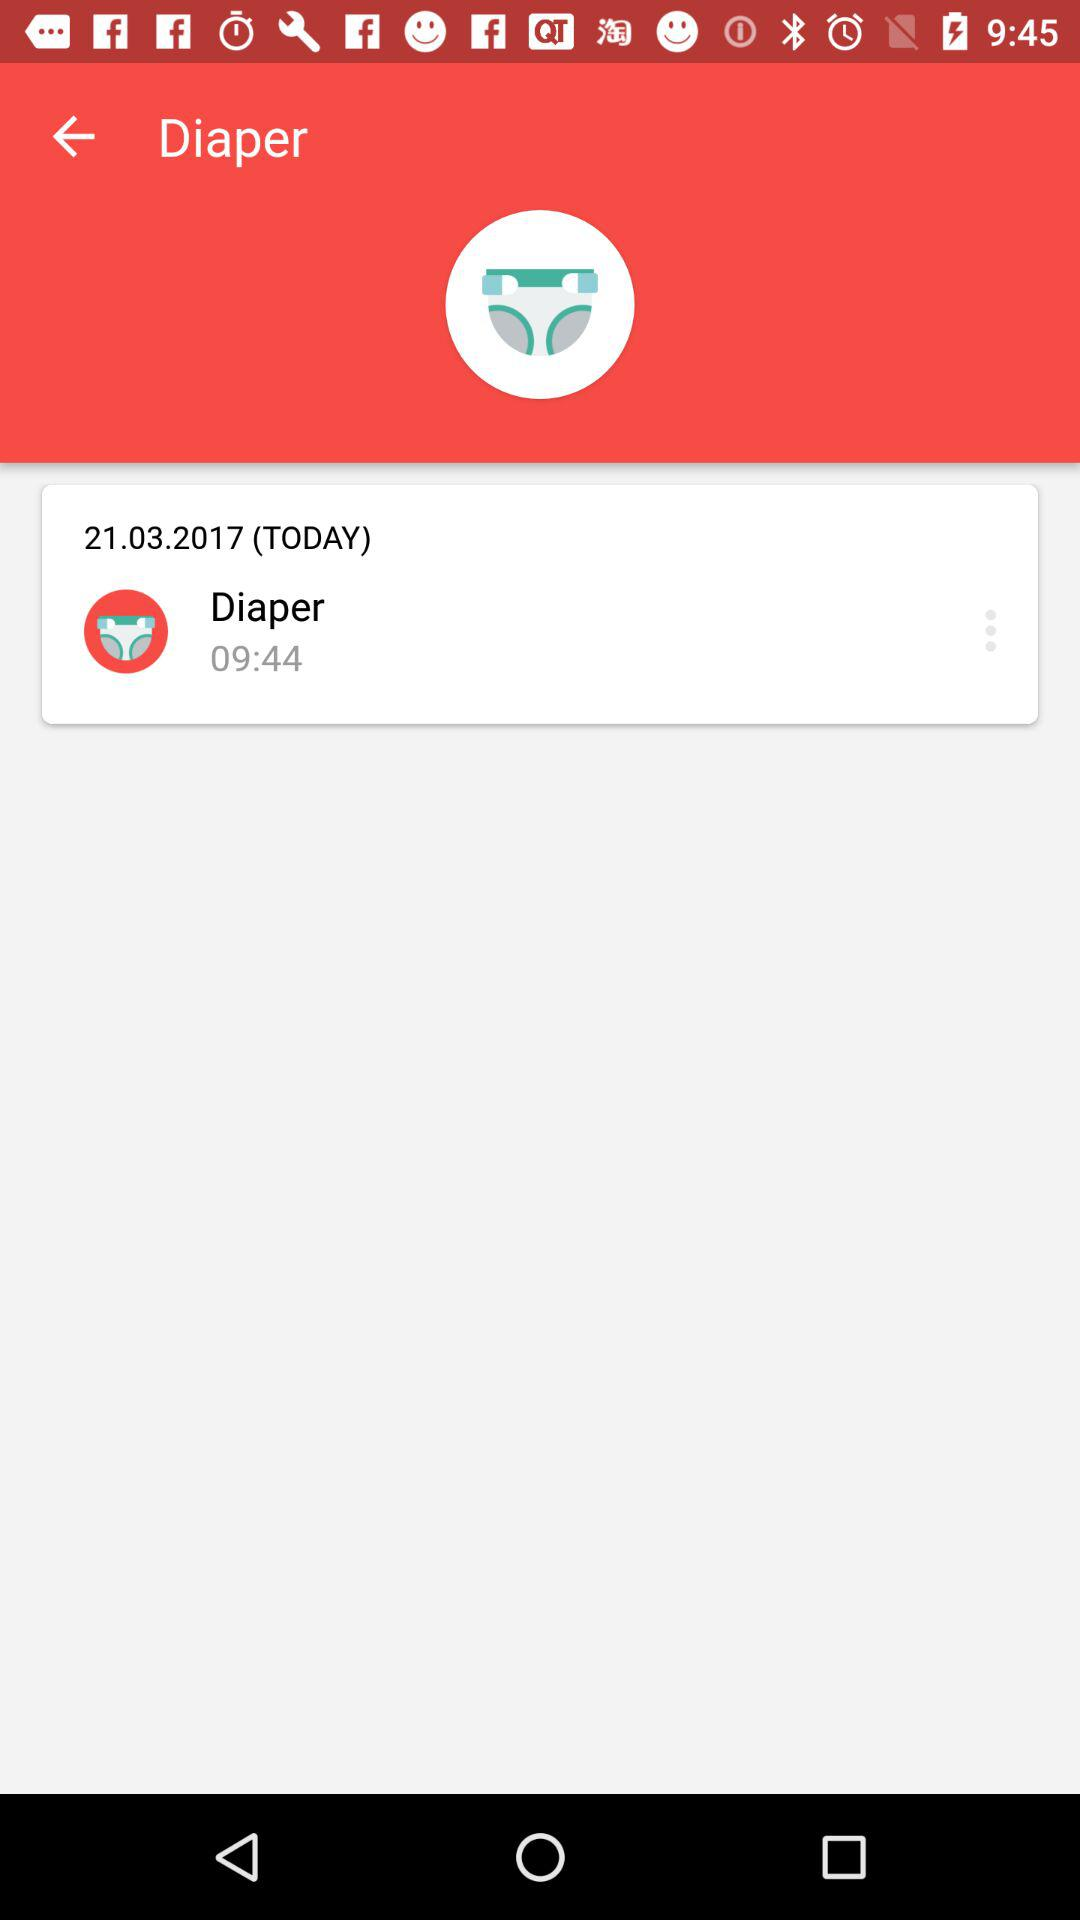What is the mentioned date? The mentioned date is March 21, 2017. 